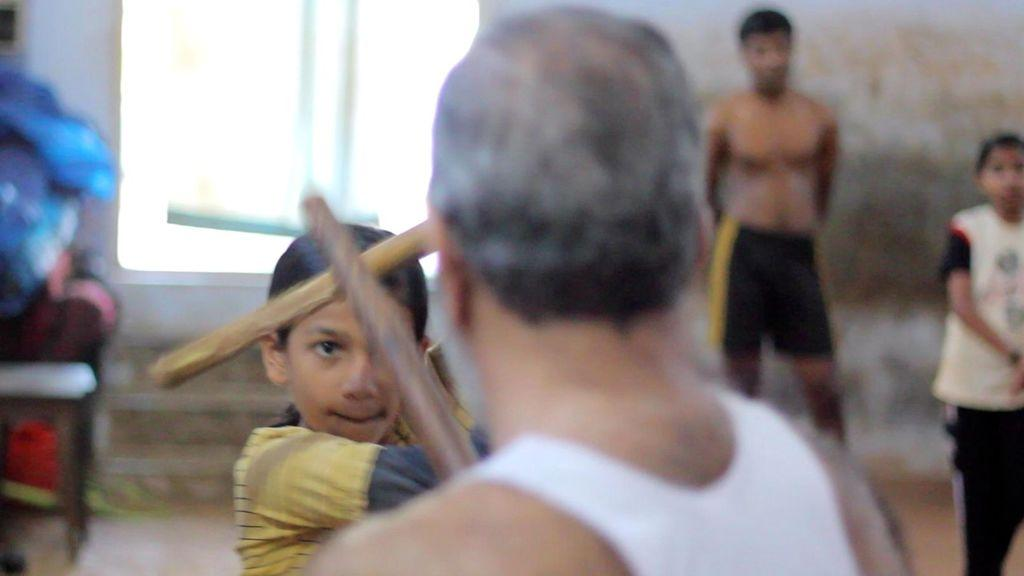What are the two persons holding in the image? The two persons are holding sticks in the image. What can be seen in the background of the image? There are items visible in the background of the image, as well as two persons standing. What type of architectural feature is present in the background of the image? There is a wall in the background of the image. Is there any opening in the wall visible in the image? Yes, there is a window in the background of the image. What type of duck can be seen making an error in the image? There is no duck present in the image, nor is there any indication of an error being made. 